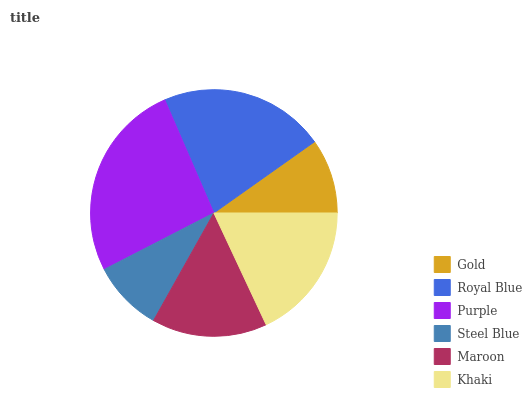Is Steel Blue the minimum?
Answer yes or no. Yes. Is Purple the maximum?
Answer yes or no. Yes. Is Royal Blue the minimum?
Answer yes or no. No. Is Royal Blue the maximum?
Answer yes or no. No. Is Royal Blue greater than Gold?
Answer yes or no. Yes. Is Gold less than Royal Blue?
Answer yes or no. Yes. Is Gold greater than Royal Blue?
Answer yes or no. No. Is Royal Blue less than Gold?
Answer yes or no. No. Is Khaki the high median?
Answer yes or no. Yes. Is Maroon the low median?
Answer yes or no. Yes. Is Maroon the high median?
Answer yes or no. No. Is Khaki the low median?
Answer yes or no. No. 